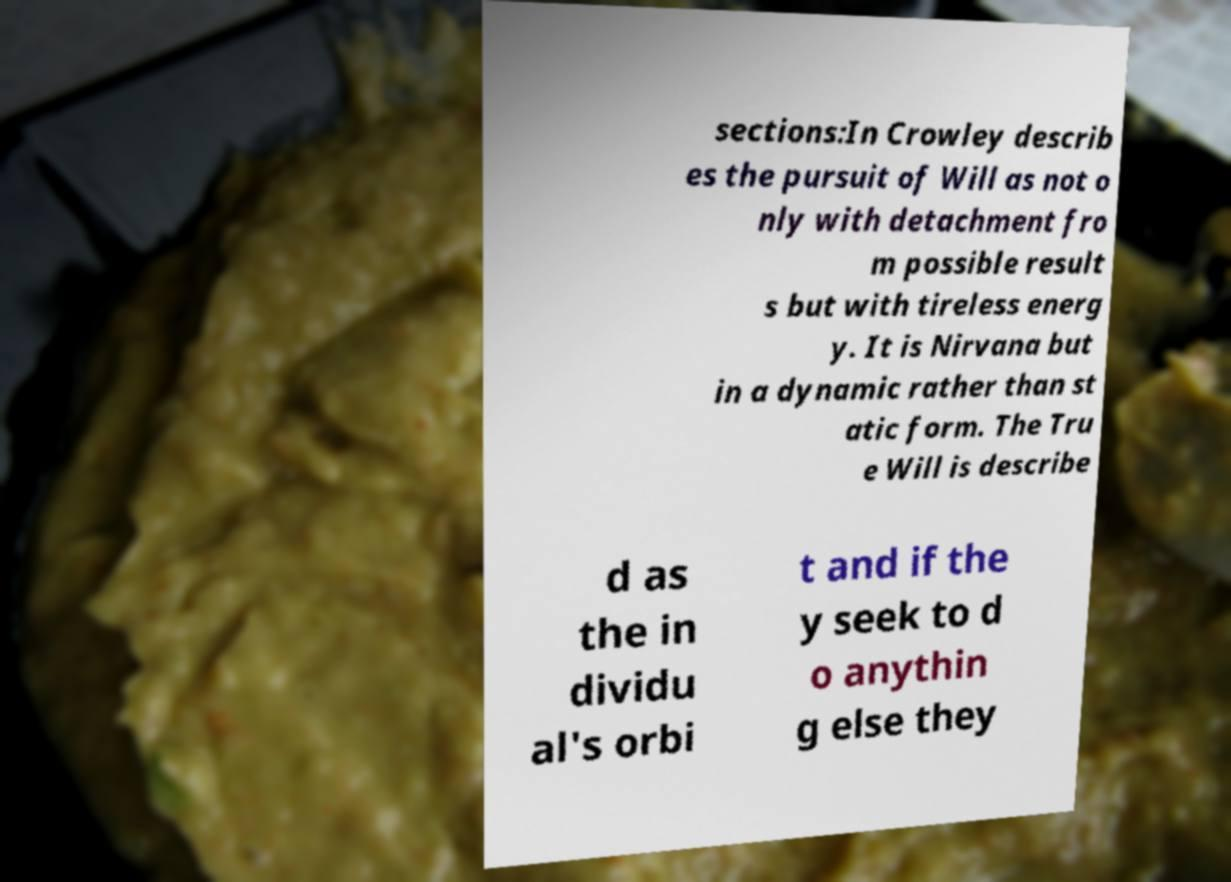There's text embedded in this image that I need extracted. Can you transcribe it verbatim? sections:In Crowley describ es the pursuit of Will as not o nly with detachment fro m possible result s but with tireless energ y. It is Nirvana but in a dynamic rather than st atic form. The Tru e Will is describe d as the in dividu al's orbi t and if the y seek to d o anythin g else they 